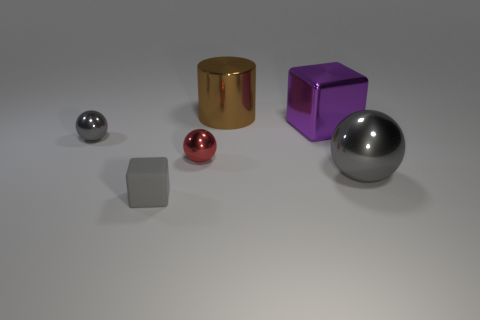What is the material of the tiny ball that is the same color as the tiny matte object?
Your answer should be compact. Metal. How many other objects are the same color as the matte cube?
Give a very brief answer. 2. What is the material of the gray ball that is right of the large purple block that is to the right of the brown metallic cylinder?
Give a very brief answer. Metal. Are there fewer tiny red shiny objects to the right of the tiny red ball than tiny purple matte objects?
Your response must be concise. No. What is the shape of the big brown thing behind the tiny gray sphere?
Provide a succinct answer. Cylinder. Is the size of the red sphere the same as the gray thing that is on the right side of the big purple thing?
Ensure brevity in your answer.  No. Are there any large cylinders made of the same material as the purple cube?
Ensure brevity in your answer.  Yes. What number of cubes are either tiny things or small gray metal things?
Provide a short and direct response. 1. Are there any large objects that are to the left of the block that is to the left of the brown metal cylinder?
Your answer should be compact. No. Is the number of blue cubes less than the number of brown metallic things?
Offer a very short reply. Yes. 